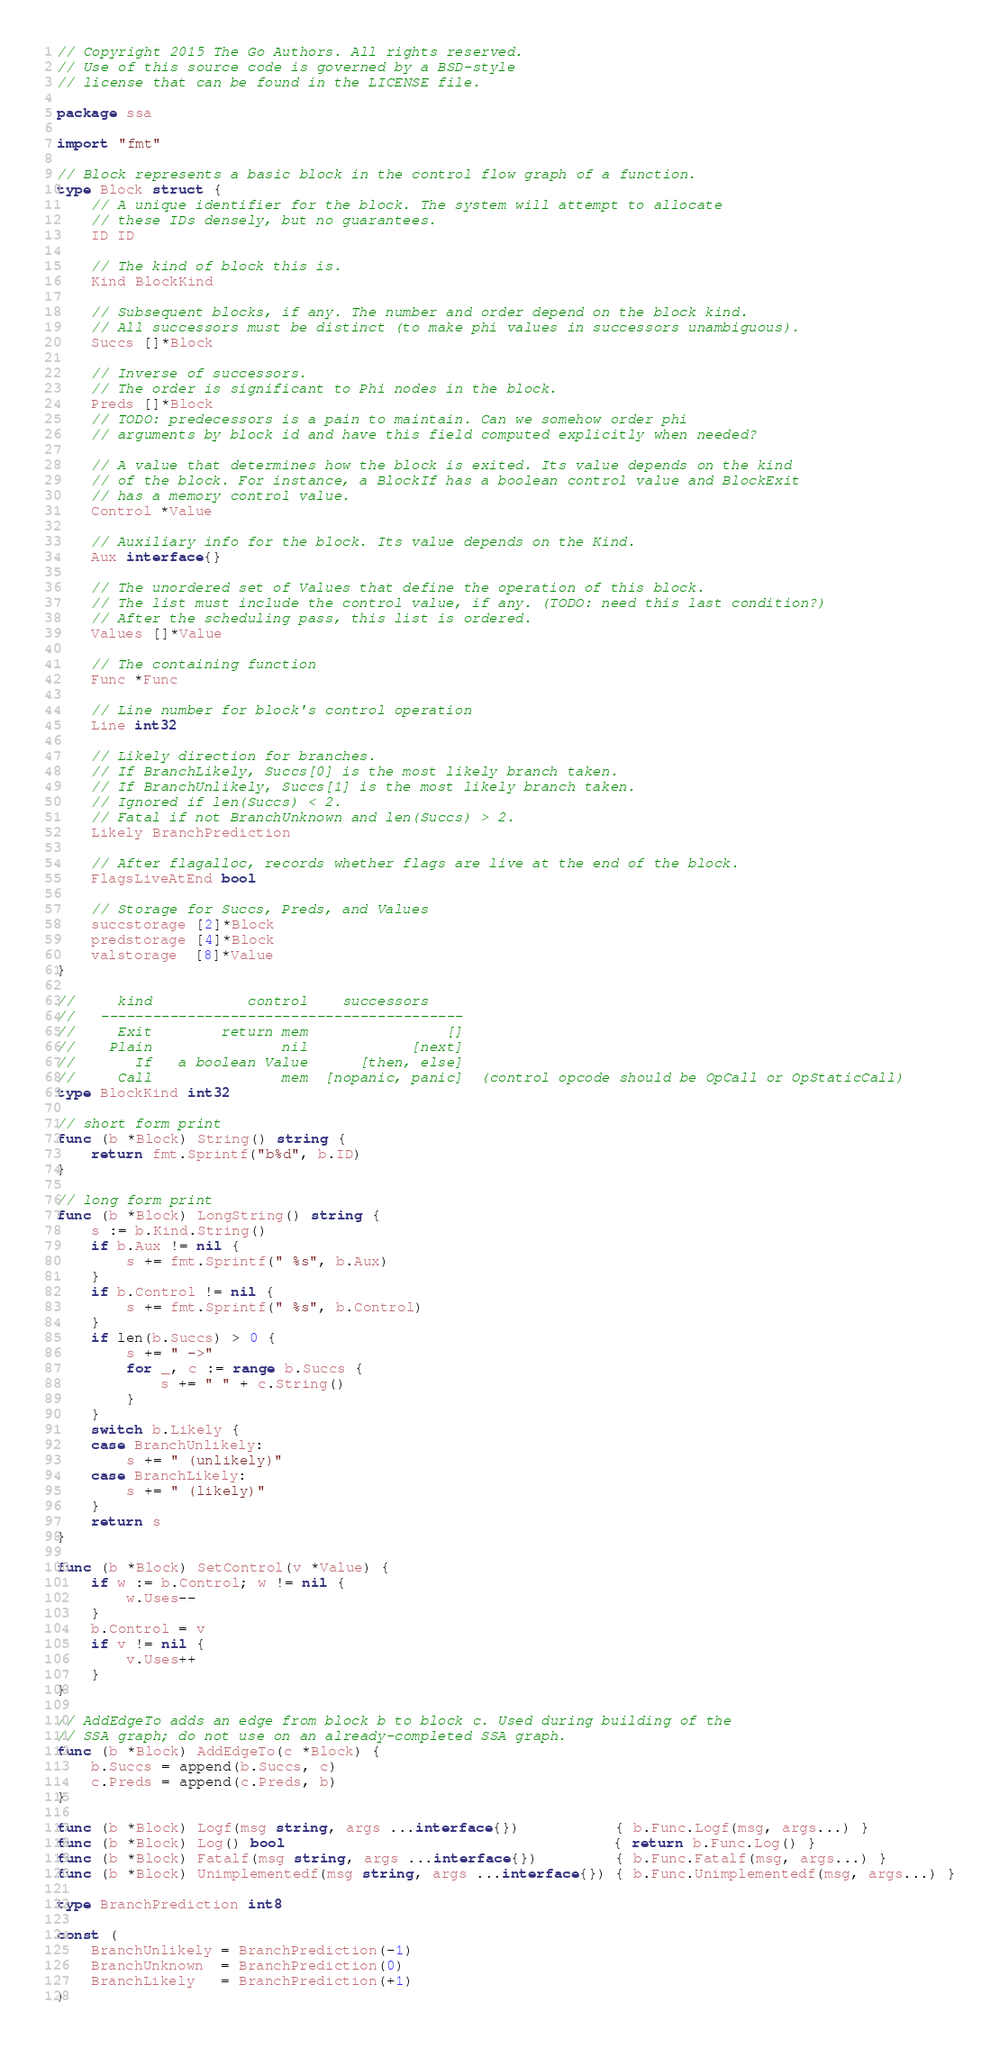Convert code to text. <code><loc_0><loc_0><loc_500><loc_500><_Go_>// Copyright 2015 The Go Authors. All rights reserved.
// Use of this source code is governed by a BSD-style
// license that can be found in the LICENSE file.

package ssa

import "fmt"

// Block represents a basic block in the control flow graph of a function.
type Block struct {
	// A unique identifier for the block. The system will attempt to allocate
	// these IDs densely, but no guarantees.
	ID ID

	// The kind of block this is.
	Kind BlockKind

	// Subsequent blocks, if any. The number and order depend on the block kind.
	// All successors must be distinct (to make phi values in successors unambiguous).
	Succs []*Block

	// Inverse of successors.
	// The order is significant to Phi nodes in the block.
	Preds []*Block
	// TODO: predecessors is a pain to maintain. Can we somehow order phi
	// arguments by block id and have this field computed explicitly when needed?

	// A value that determines how the block is exited. Its value depends on the kind
	// of the block. For instance, a BlockIf has a boolean control value and BlockExit
	// has a memory control value.
	Control *Value

	// Auxiliary info for the block. Its value depends on the Kind.
	Aux interface{}

	// The unordered set of Values that define the operation of this block.
	// The list must include the control value, if any. (TODO: need this last condition?)
	// After the scheduling pass, this list is ordered.
	Values []*Value

	// The containing function
	Func *Func

	// Line number for block's control operation
	Line int32

	// Likely direction for branches.
	// If BranchLikely, Succs[0] is the most likely branch taken.
	// If BranchUnlikely, Succs[1] is the most likely branch taken.
	// Ignored if len(Succs) < 2.
	// Fatal if not BranchUnknown and len(Succs) > 2.
	Likely BranchPrediction

	// After flagalloc, records whether flags are live at the end of the block.
	FlagsLiveAtEnd bool

	// Storage for Succs, Preds, and Values
	succstorage [2]*Block
	predstorage [4]*Block
	valstorage  [8]*Value
}

//     kind           control    successors
//   ------------------------------------------
//     Exit        return mem                []
//    Plain               nil            [next]
//       If   a boolean Value      [then, else]
//     Call               mem  [nopanic, panic]  (control opcode should be OpCall or OpStaticCall)
type BlockKind int32

// short form print
func (b *Block) String() string {
	return fmt.Sprintf("b%d", b.ID)
}

// long form print
func (b *Block) LongString() string {
	s := b.Kind.String()
	if b.Aux != nil {
		s += fmt.Sprintf(" %s", b.Aux)
	}
	if b.Control != nil {
		s += fmt.Sprintf(" %s", b.Control)
	}
	if len(b.Succs) > 0 {
		s += " ->"
		for _, c := range b.Succs {
			s += " " + c.String()
		}
	}
	switch b.Likely {
	case BranchUnlikely:
		s += " (unlikely)"
	case BranchLikely:
		s += " (likely)"
	}
	return s
}

func (b *Block) SetControl(v *Value) {
	if w := b.Control; w != nil {
		w.Uses--
	}
	b.Control = v
	if v != nil {
		v.Uses++
	}
}

// AddEdgeTo adds an edge from block b to block c. Used during building of the
// SSA graph; do not use on an already-completed SSA graph.
func (b *Block) AddEdgeTo(c *Block) {
	b.Succs = append(b.Succs, c)
	c.Preds = append(c.Preds, b)
}

func (b *Block) Logf(msg string, args ...interface{})           { b.Func.Logf(msg, args...) }
func (b *Block) Log() bool                                      { return b.Func.Log() }
func (b *Block) Fatalf(msg string, args ...interface{})         { b.Func.Fatalf(msg, args...) }
func (b *Block) Unimplementedf(msg string, args ...interface{}) { b.Func.Unimplementedf(msg, args...) }

type BranchPrediction int8

const (
	BranchUnlikely = BranchPrediction(-1)
	BranchUnknown  = BranchPrediction(0)
	BranchLikely   = BranchPrediction(+1)
)
</code> 